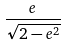Convert formula to latex. <formula><loc_0><loc_0><loc_500><loc_500>\frac { e } { \sqrt { 2 - e ^ { 2 } } }</formula> 